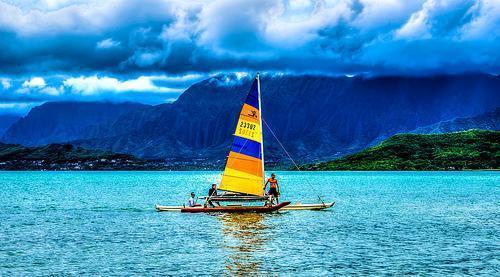How many orange stripes are on the sail?
Give a very brief answer. 2. 